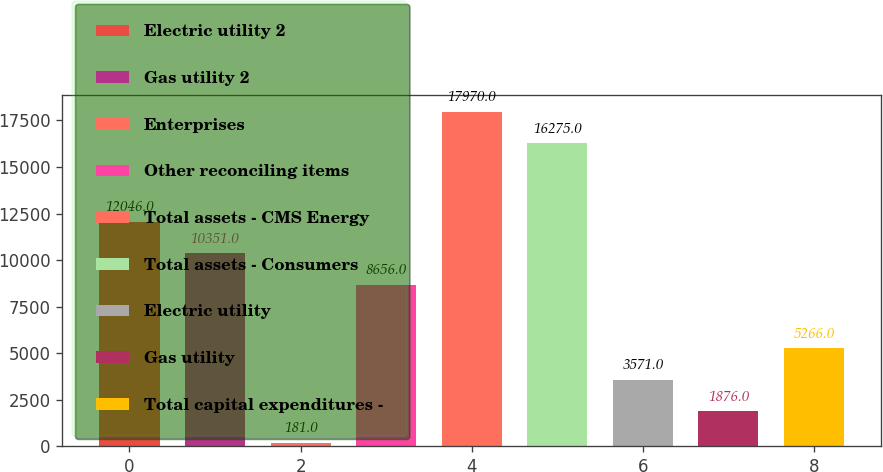Convert chart to OTSL. <chart><loc_0><loc_0><loc_500><loc_500><bar_chart><fcel>Electric utility 2<fcel>Gas utility 2<fcel>Enterprises<fcel>Other reconciling items<fcel>Total assets - CMS Energy<fcel>Total assets - Consumers<fcel>Electric utility<fcel>Gas utility<fcel>Total capital expenditures -<nl><fcel>12046<fcel>10351<fcel>181<fcel>8656<fcel>17970<fcel>16275<fcel>3571<fcel>1876<fcel>5266<nl></chart> 